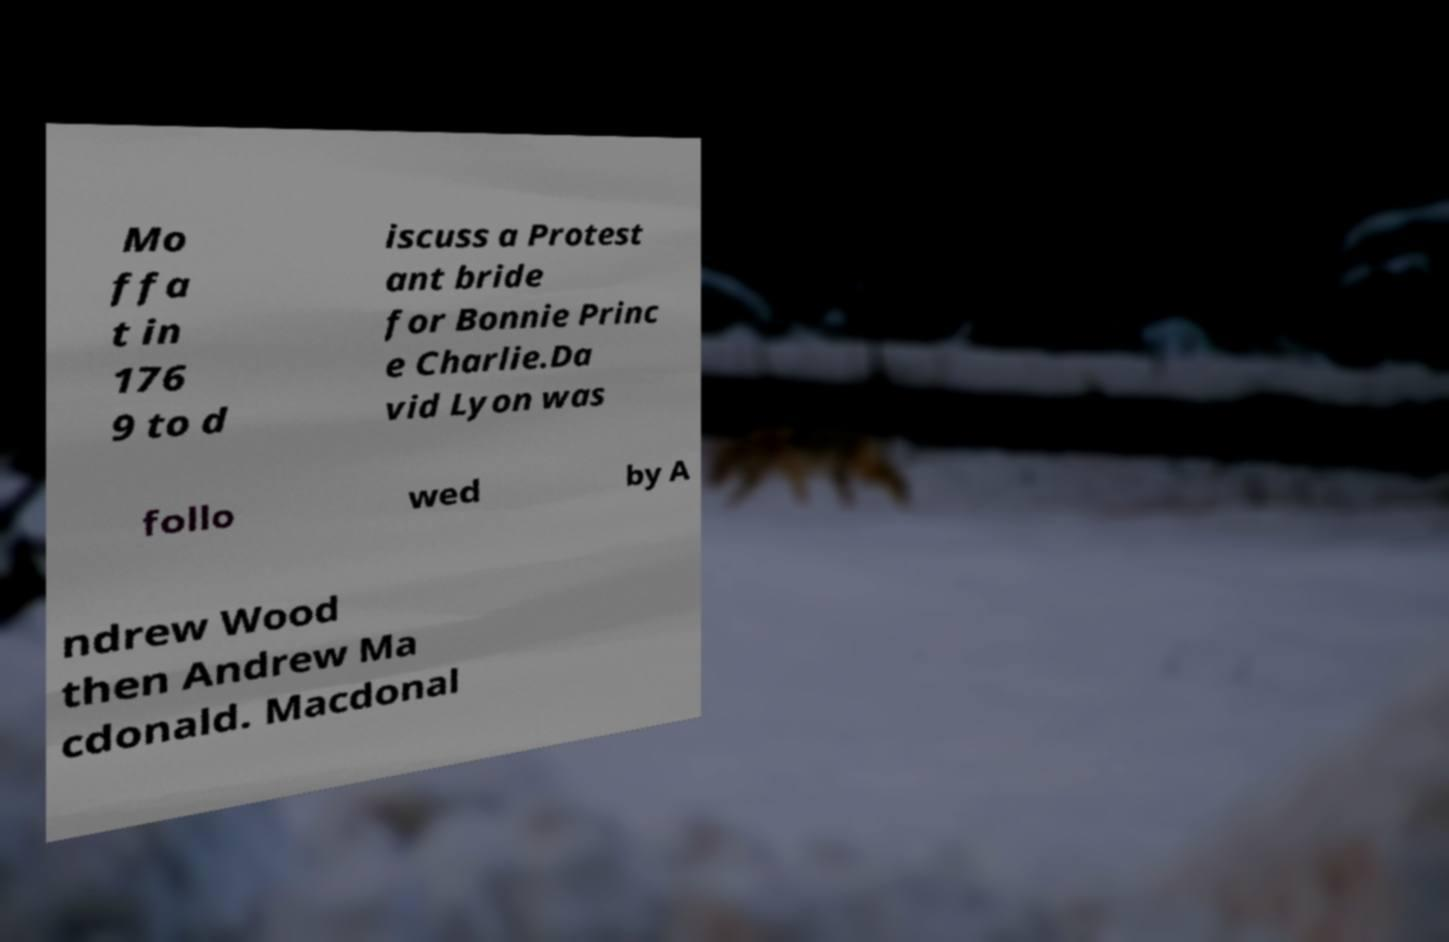Please identify and transcribe the text found in this image. Mo ffa t in 176 9 to d iscuss a Protest ant bride for Bonnie Princ e Charlie.Da vid Lyon was follo wed by A ndrew Wood then Andrew Ma cdonald. Macdonal 